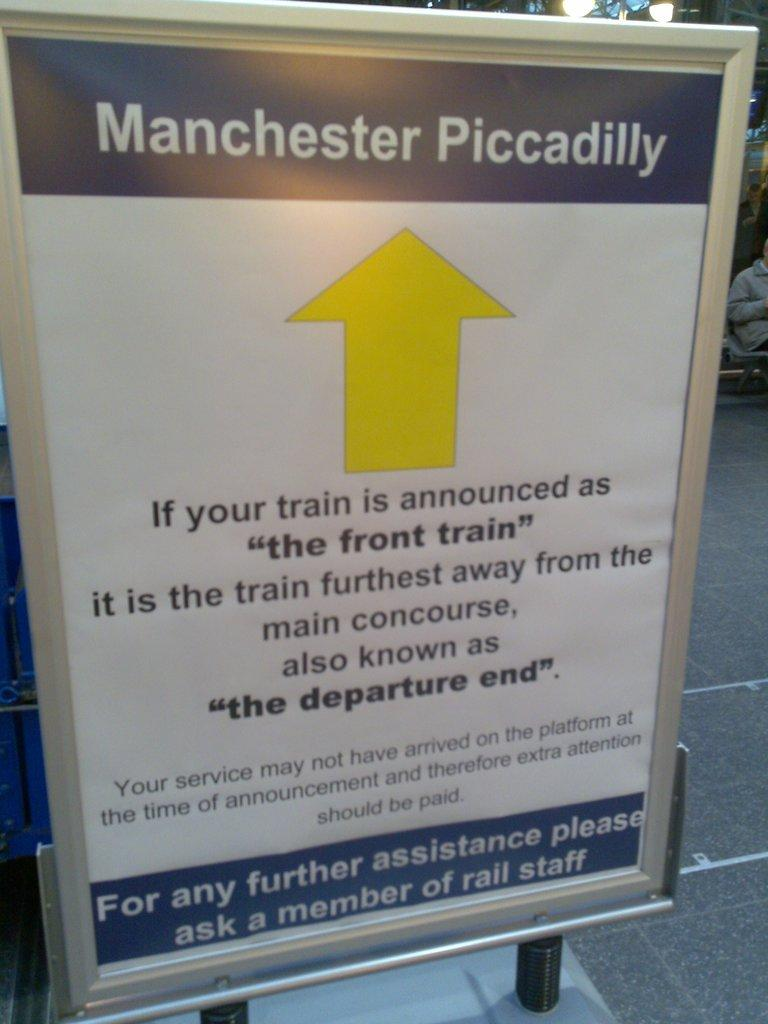What is the main subject of the image? The main subject of the image is a notice board. Are there any specific markings or symbols on the notice board? Yes, there is a yellow arrow mark on the notice board. Can you see a crown on the notice board in the image? No, there is no crown present on the notice board in the image. 